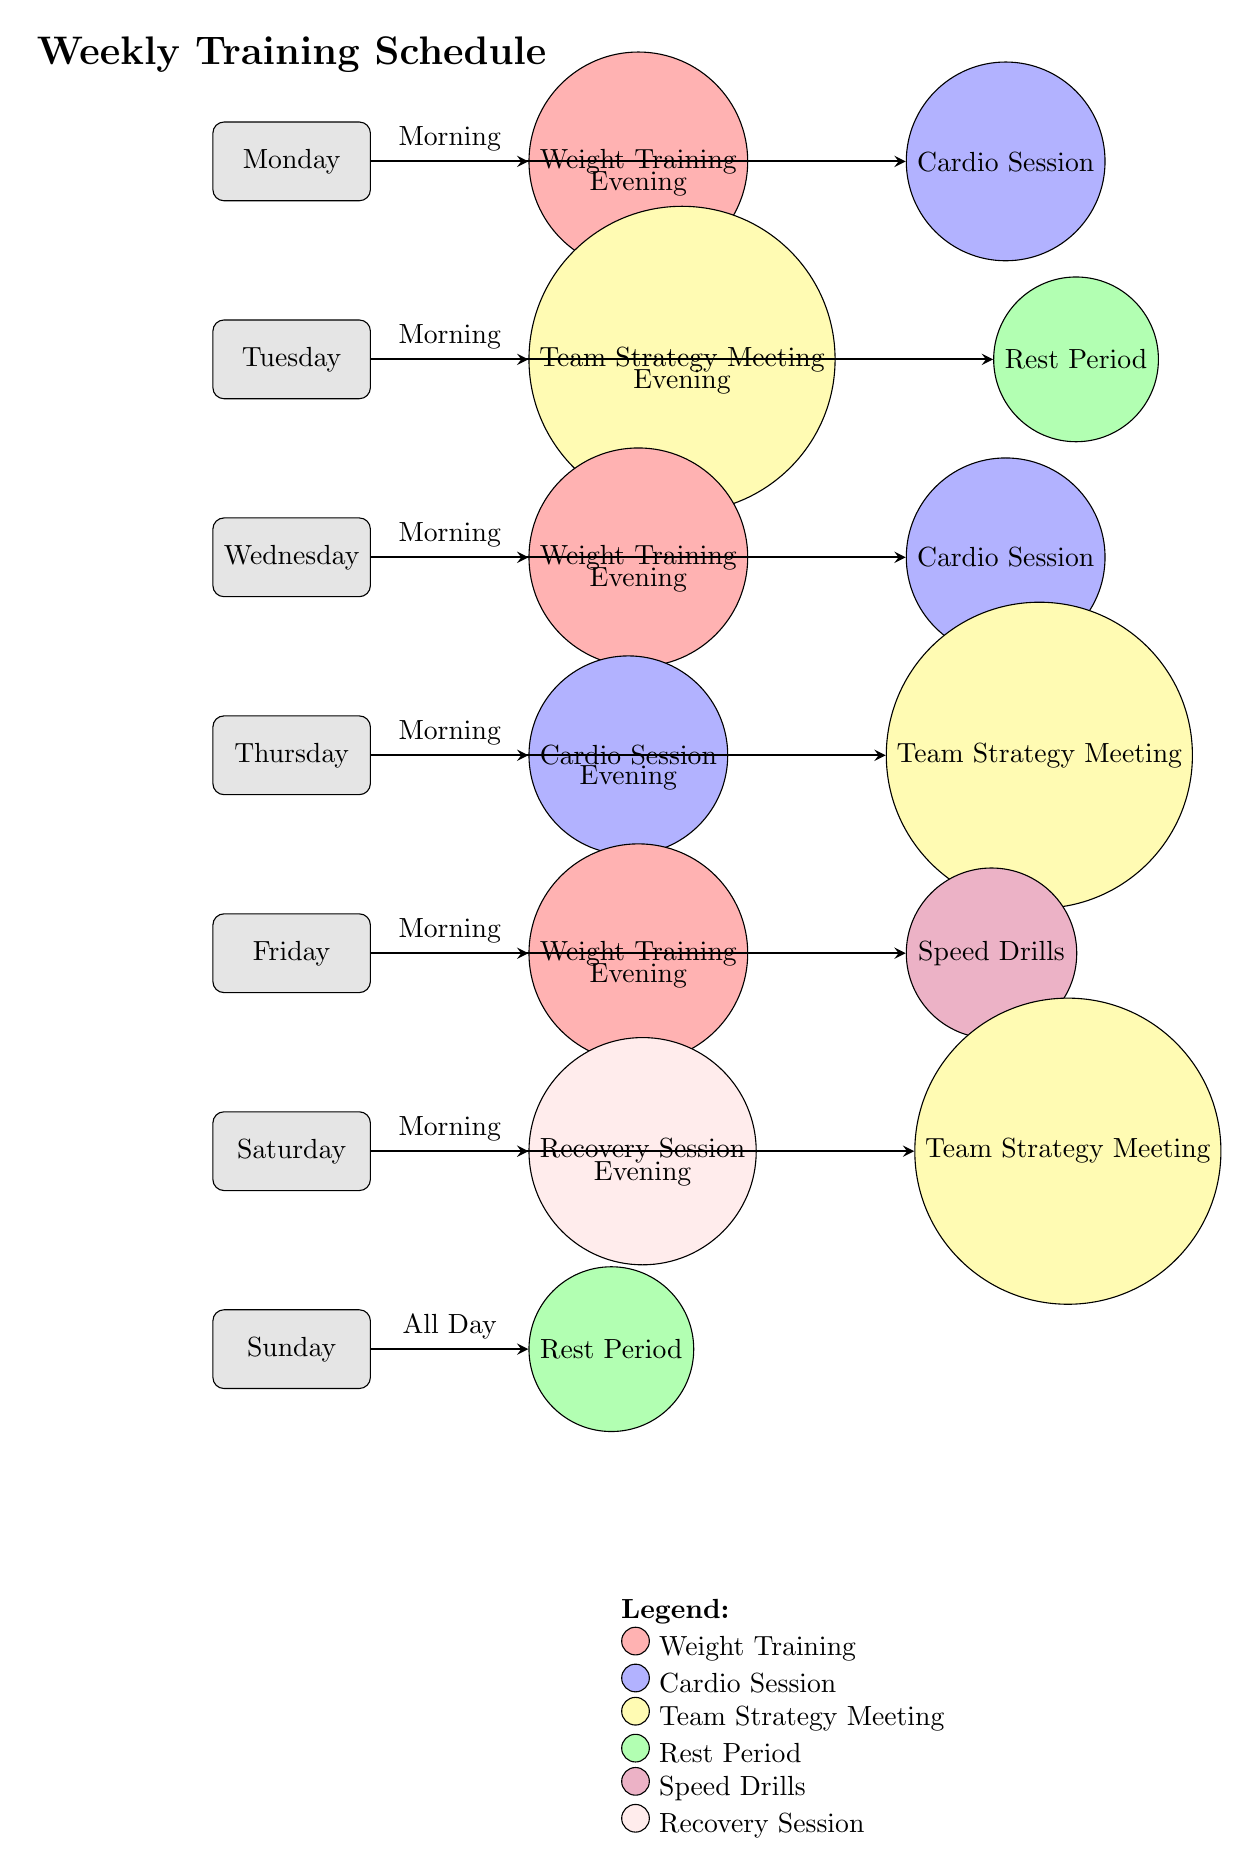What activities are scheduled for Monday morning? In the diagram, Monday morning is linked to the "Weight Training" activity through an arrow from Monday indicating it occurs in the morning.
Answer: Weight Training How many days include a Team Strategy Meeting? By counting the nodes connected to days that mention "Team Strategy Meeting," we find it occurs on Tuesday, Thursday, and Saturday. Therefore, there are three days with this activity.
Answer: Three What color represents the Rest Period? The color coding demonstrates that "Rest Period" is represented in green.
Answer: Green Which day has both a Weight Training session and a Speed Drill? Checking the connections, Friday contains "Weight Training" in the morning and "Speed Drills" in the evening. Thus, Friday has both activities.
Answer: Friday On which days are cardio sessions scheduled? Evaluating the flow of activities, cardio sessions are held on Monday, Wednesday, and Thursday. Thus, those three days include cardio sessions.
Answer: Monday, Wednesday, Thursday How many total rest periods are shown in the schedule? The diagram indicates there are two rest periods: one on Tuesday evening and another on Sunday all day, resulting in two total rest periods.
Answer: Two Which activity is scheduled in the evening on Saturday? Looking at the evening activities on Saturday, the diagram shows a "Team Strategy Meeting" scheduled for that time.
Answer: Team Strategy Meeting On which day is a Recovery Session held? By analyzing the schedule, "Recovery Session" occurs on Saturday morning as indicated in the nodes.
Answer: Saturday What is the total number of activities scheduled for the week? The activities appear to include Weight Training (3), Cardio Sessions (3), Team Strategy Meetings (3), Rest Periods (2), Speed Drills (1), and Recovery Session (1), totaling 13 activities across the week.
Answer: Thirteen 